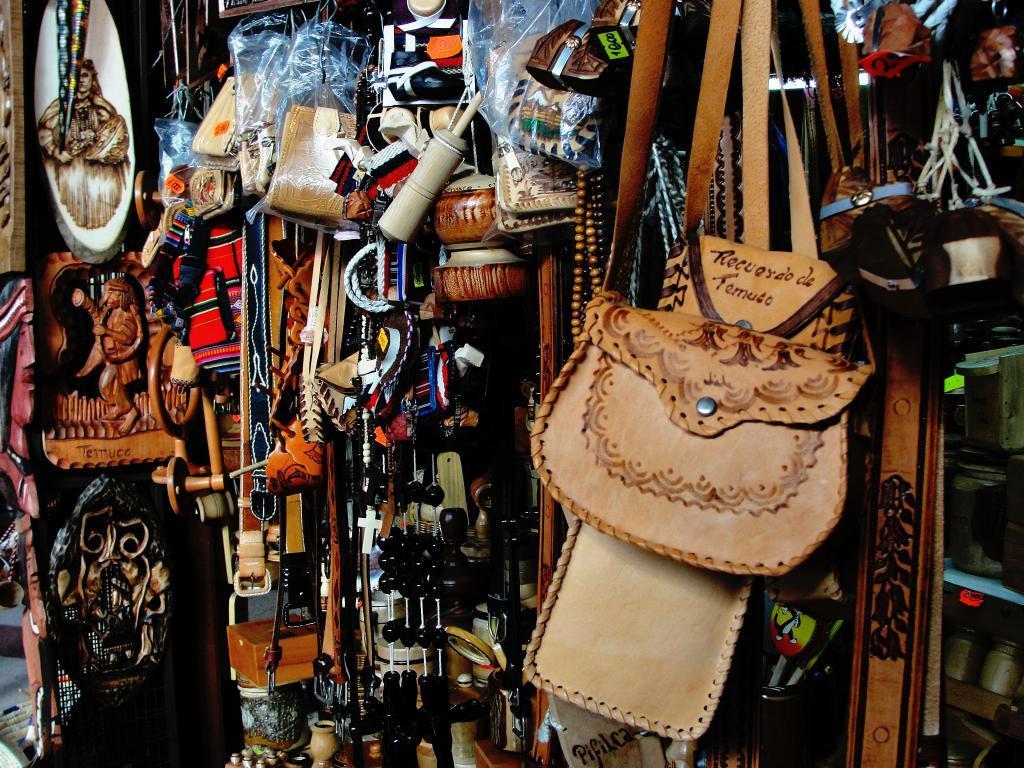Could you give a brief overview of what you see in this image? In the foreground of this image, we see many objects like sling bags, belts, hangings, pots, few wall hanging sculptures and bags. 